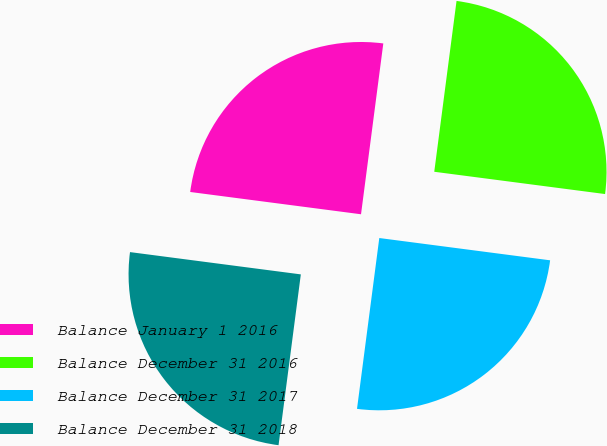Convert chart. <chart><loc_0><loc_0><loc_500><loc_500><pie_chart><fcel>Balance January 1 2016<fcel>Balance December 31 2016<fcel>Balance December 31 2017<fcel>Balance December 31 2018<nl><fcel>25.0%<fcel>25.0%<fcel>25.0%<fcel>25.0%<nl></chart> 